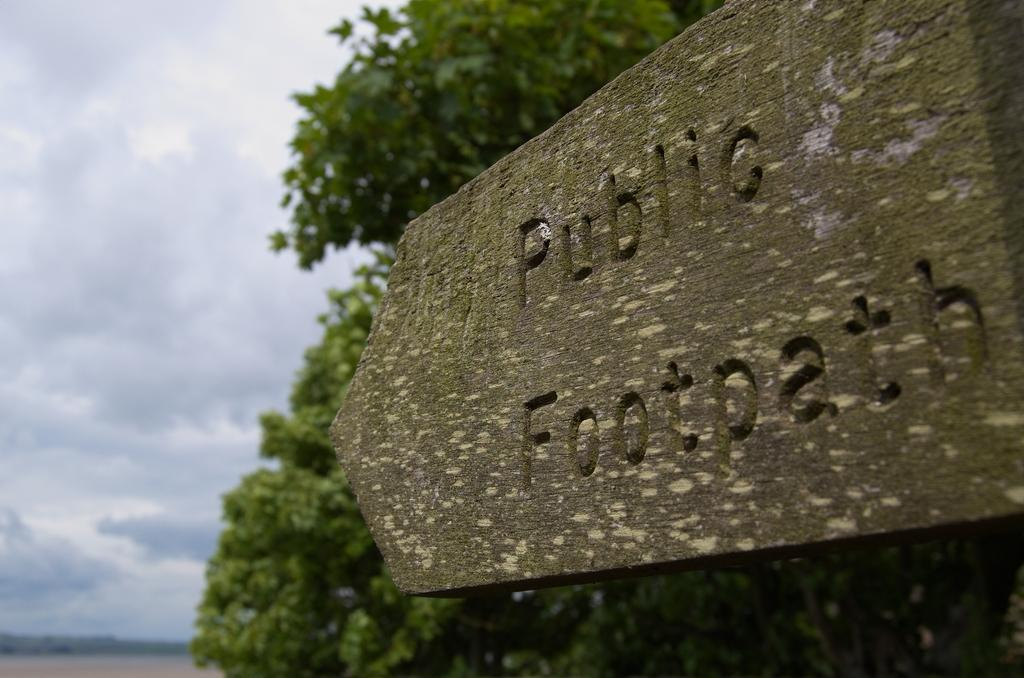What type of vegetation can be seen in the image? There are trees in the image. What object is located in the middle of the image? There is a board in the middle of the image. What can be seen in the sky in the image? There are clouds in the sky. Where is the waste disposal unit located in the image? There is no waste disposal unit present in the image. What direction is the yoke pointing in the image? There is no yoke present in the image. 